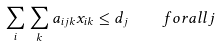<formula> <loc_0><loc_0><loc_500><loc_500>\sum _ { i } \sum _ { k } a _ { i j k } x _ { i k } \leq d _ { j } \quad f o r a l l j</formula> 